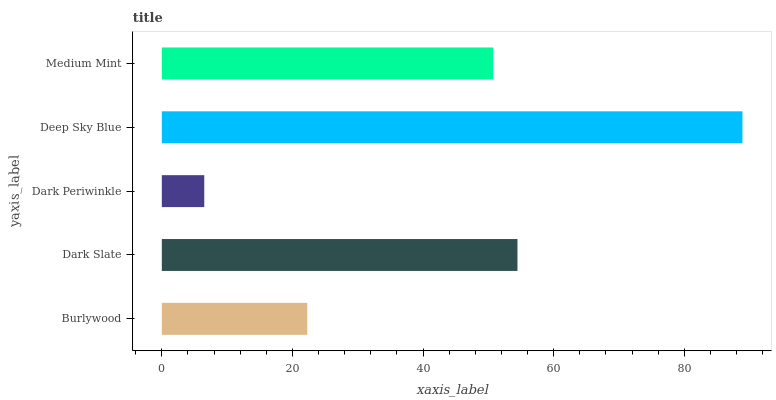Is Dark Periwinkle the minimum?
Answer yes or no. Yes. Is Deep Sky Blue the maximum?
Answer yes or no. Yes. Is Dark Slate the minimum?
Answer yes or no. No. Is Dark Slate the maximum?
Answer yes or no. No. Is Dark Slate greater than Burlywood?
Answer yes or no. Yes. Is Burlywood less than Dark Slate?
Answer yes or no. Yes. Is Burlywood greater than Dark Slate?
Answer yes or no. No. Is Dark Slate less than Burlywood?
Answer yes or no. No. Is Medium Mint the high median?
Answer yes or no. Yes. Is Medium Mint the low median?
Answer yes or no. Yes. Is Dark Slate the high median?
Answer yes or no. No. Is Deep Sky Blue the low median?
Answer yes or no. No. 